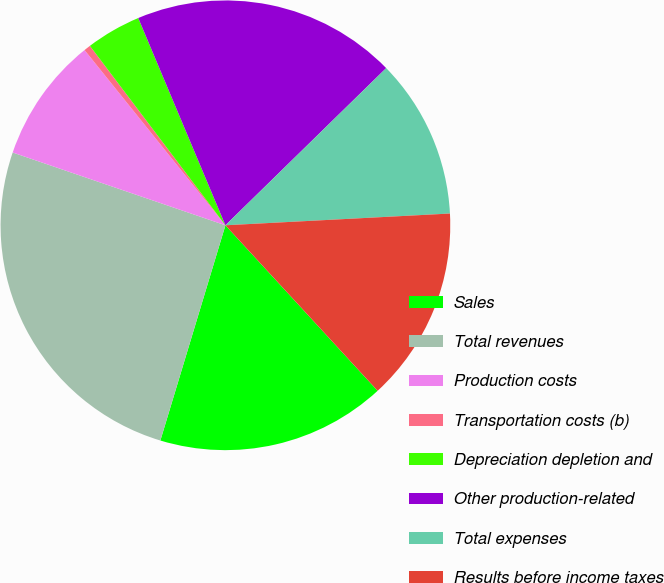Convert chart. <chart><loc_0><loc_0><loc_500><loc_500><pie_chart><fcel>Sales<fcel>Total revenues<fcel>Production costs<fcel>Transportation costs (b)<fcel>Depreciation depletion and<fcel>Other production-related<fcel>Total expenses<fcel>Results before income taxes<nl><fcel>16.51%<fcel>25.58%<fcel>8.98%<fcel>0.48%<fcel>3.96%<fcel>19.02%<fcel>11.49%<fcel>14.0%<nl></chart> 